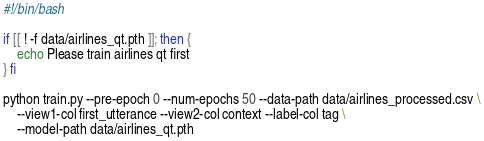<code> <loc_0><loc_0><loc_500><loc_500><_Bash_>#!/bin/bash

if [[ ! -f data/airlines_qt.pth ]]; then {
    echo Please train airlines qt first
} fi

python train.py --pre-epoch 0 --num-epochs 50 --data-path data/airlines_processed.csv \
    --view1-col first_utterance --view2-col context --label-col tag \
    --model-path data/airlines_qt.pth
</code> 